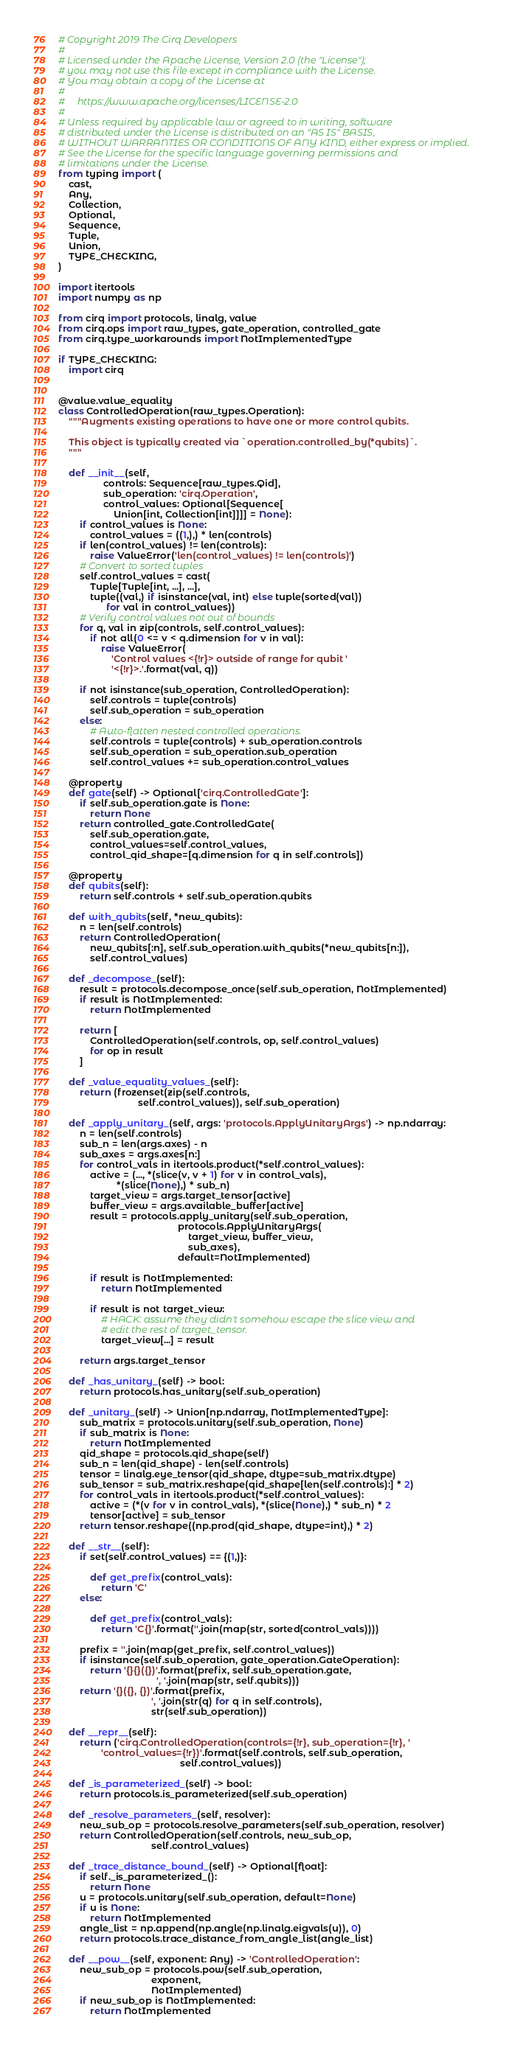<code> <loc_0><loc_0><loc_500><loc_500><_Python_># Copyright 2019 The Cirq Developers
#
# Licensed under the Apache License, Version 2.0 (the "License");
# you may not use this file except in compliance with the License.
# You may obtain a copy of the License at
#
#     https://www.apache.org/licenses/LICENSE-2.0
#
# Unless required by applicable law or agreed to in writing, software
# distributed under the License is distributed on an "AS IS" BASIS,
# WITHOUT WARRANTIES OR CONDITIONS OF ANY KIND, either express or implied.
# See the License for the specific language governing permissions and
# limitations under the License.
from typing import (
    cast,
    Any,
    Collection,
    Optional,
    Sequence,
    Tuple,
    Union,
    TYPE_CHECKING,
)

import itertools
import numpy as np

from cirq import protocols, linalg, value
from cirq.ops import raw_types, gate_operation, controlled_gate
from cirq.type_workarounds import NotImplementedType

if TYPE_CHECKING:
    import cirq


@value.value_equality
class ControlledOperation(raw_types.Operation):
    """Augments existing operations to have one or more control qubits.

    This object is typically created via `operation.controlled_by(*qubits)`.
    """

    def __init__(self,
                 controls: Sequence[raw_types.Qid],
                 sub_operation: 'cirq.Operation',
                 control_values: Optional[Sequence[
                     Union[int, Collection[int]]]] = None):
        if control_values is None:
            control_values = ((1,),) * len(controls)
        if len(control_values) != len(controls):
            raise ValueError('len(control_values) != len(controls)')
        # Convert to sorted tuples
        self.control_values = cast(
            Tuple[Tuple[int, ...], ...],
            tuple((val,) if isinstance(val, int) else tuple(sorted(val))
                  for val in control_values))
        # Verify control values not out of bounds
        for q, val in zip(controls, self.control_values):
            if not all(0 <= v < q.dimension for v in val):
                raise ValueError(
                    'Control values <{!r}> outside of range for qubit '
                    '<{!r}>.'.format(val, q))

        if not isinstance(sub_operation, ControlledOperation):
            self.controls = tuple(controls)
            self.sub_operation = sub_operation
        else:
            # Auto-flatten nested controlled operations.
            self.controls = tuple(controls) + sub_operation.controls
            self.sub_operation = sub_operation.sub_operation
            self.control_values += sub_operation.control_values

    @property
    def gate(self) -> Optional['cirq.ControlledGate']:
        if self.sub_operation.gate is None:
            return None
        return controlled_gate.ControlledGate(
            self.sub_operation.gate,
            control_values=self.control_values,
            control_qid_shape=[q.dimension for q in self.controls])

    @property
    def qubits(self):
        return self.controls + self.sub_operation.qubits

    def with_qubits(self, *new_qubits):
        n = len(self.controls)
        return ControlledOperation(
            new_qubits[:n], self.sub_operation.with_qubits(*new_qubits[n:]),
            self.control_values)

    def _decompose_(self):
        result = protocols.decompose_once(self.sub_operation, NotImplemented)
        if result is NotImplemented:
            return NotImplemented

        return [
            ControlledOperation(self.controls, op, self.control_values)
            for op in result
        ]

    def _value_equality_values_(self):
        return (frozenset(zip(self.controls,
                              self.control_values)), self.sub_operation)

    def _apply_unitary_(self, args: 'protocols.ApplyUnitaryArgs') -> np.ndarray:
        n = len(self.controls)
        sub_n = len(args.axes) - n
        sub_axes = args.axes[n:]
        for control_vals in itertools.product(*self.control_values):
            active = (..., *(slice(v, v + 1) for v in control_vals),
                      *(slice(None),) * sub_n)
            target_view = args.target_tensor[active]
            buffer_view = args.available_buffer[active]
            result = protocols.apply_unitary(self.sub_operation,
                                             protocols.ApplyUnitaryArgs(
                                                 target_view, buffer_view,
                                                 sub_axes),
                                             default=NotImplemented)

            if result is NotImplemented:
                return NotImplemented

            if result is not target_view:
                # HACK: assume they didn't somehow escape the slice view and
                # edit the rest of target_tensor.
                target_view[...] = result

        return args.target_tensor

    def _has_unitary_(self) -> bool:
        return protocols.has_unitary(self.sub_operation)

    def _unitary_(self) -> Union[np.ndarray, NotImplementedType]:
        sub_matrix = protocols.unitary(self.sub_operation, None)
        if sub_matrix is None:
            return NotImplemented
        qid_shape = protocols.qid_shape(self)
        sub_n = len(qid_shape) - len(self.controls)
        tensor = linalg.eye_tensor(qid_shape, dtype=sub_matrix.dtype)
        sub_tensor = sub_matrix.reshape(qid_shape[len(self.controls):] * 2)
        for control_vals in itertools.product(*self.control_values):
            active = (*(v for v in control_vals), *(slice(None),) * sub_n) * 2
            tensor[active] = sub_tensor
        return tensor.reshape((np.prod(qid_shape, dtype=int),) * 2)

    def __str__(self):
        if set(self.control_values) == {(1,)}:

            def get_prefix(control_vals):
                return 'C'
        else:

            def get_prefix(control_vals):
                return 'C{}'.format(''.join(map(str, sorted(control_vals))))

        prefix = ''.join(map(get_prefix, self.control_values))
        if isinstance(self.sub_operation, gate_operation.GateOperation):
            return '{}{}({})'.format(prefix, self.sub_operation.gate,
                                     ', '.join(map(str, self.qubits)))
        return '{}({}, {})'.format(prefix,
                                   ', '.join(str(q) for q in self.controls),
                                   str(self.sub_operation))

    def __repr__(self):
        return ('cirq.ControlledOperation(controls={!r}, sub_operation={!r}, '
                'control_values={!r})'.format(self.controls, self.sub_operation,
                                              self.control_values))

    def _is_parameterized_(self) -> bool:
        return protocols.is_parameterized(self.sub_operation)

    def _resolve_parameters_(self, resolver):
        new_sub_op = protocols.resolve_parameters(self.sub_operation, resolver)
        return ControlledOperation(self.controls, new_sub_op,
                                   self.control_values)

    def _trace_distance_bound_(self) -> Optional[float]:
        if self._is_parameterized_():
            return None
        u = protocols.unitary(self.sub_operation, default=None)
        if u is None:
            return NotImplemented
        angle_list = np.append(np.angle(np.linalg.eigvals(u)), 0)
        return protocols.trace_distance_from_angle_list(angle_list)

    def __pow__(self, exponent: Any) -> 'ControlledOperation':
        new_sub_op = protocols.pow(self.sub_operation,
                                   exponent,
                                   NotImplemented)
        if new_sub_op is NotImplemented:
            return NotImplemented</code> 